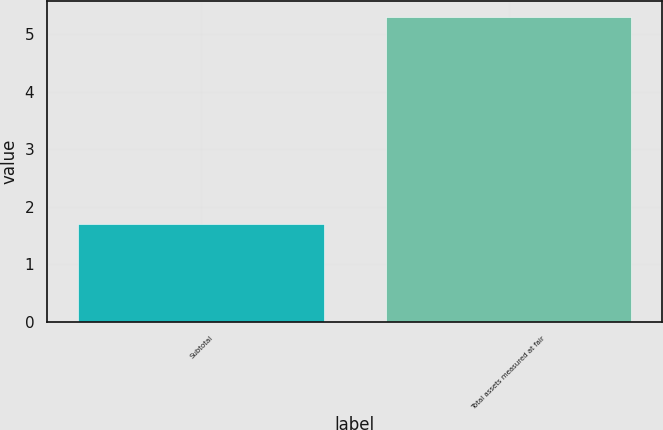Convert chart. <chart><loc_0><loc_0><loc_500><loc_500><bar_chart><fcel>Subtotal<fcel>Total assets measured at fair<nl><fcel>1.7<fcel>5.3<nl></chart> 